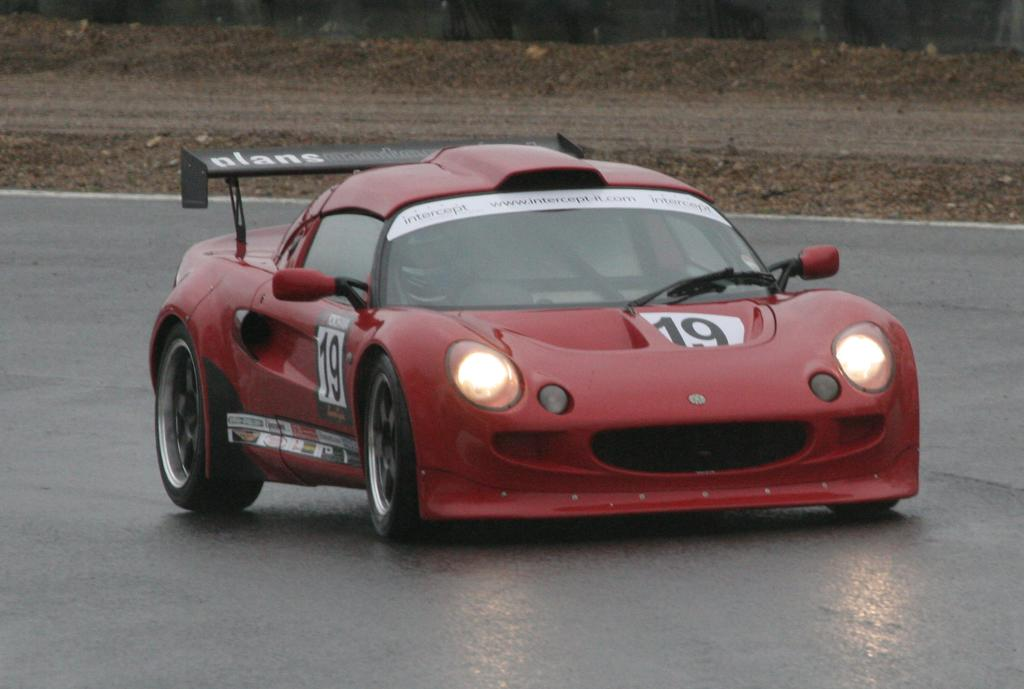Who is present in the image? There is a man in the image. What is the man wearing on his head? The man is wearing a helmet. Where is the man sitting in the image? The man is sitting inside a red car. What can be seen at the bottom of the image? There is a road visible at the bottom of the image. What is visible in the background of the image? There is an open area in the background of the image. What type of hair is visible on the man's head in the image? The man is wearing a helmet, so no hair is visible on his head in the image. 